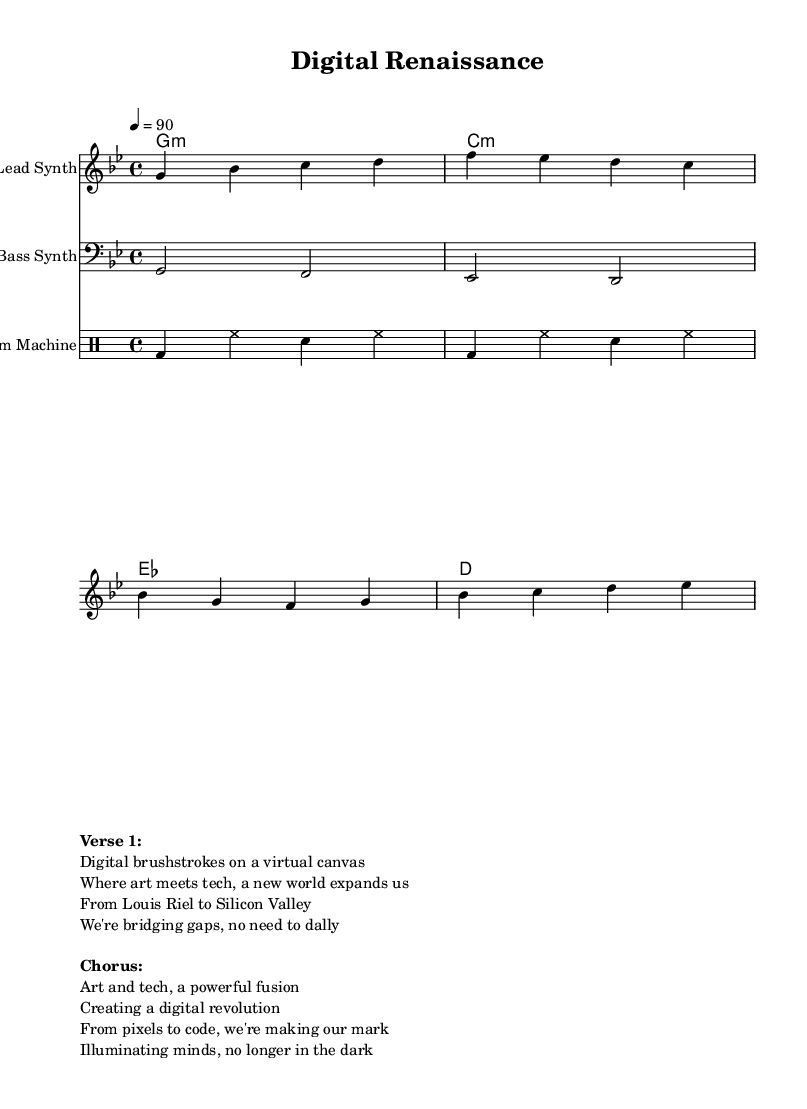What is the key signature of this music? The key signature is G minor, which has two flats: B flat and E flat. We identify the key signature from the beginning of the staff, which indicates the tonal center of the piece.
Answer: G minor What is the time signature of this music? The time signature is four-four, which means there are four beats in each measure and the quarter note gets one beat. This can be found at the beginning of the score, where the time signature is notated.
Answer: Four-four What is the tempo of the piece? The tempo marking indicates a speed of ninety beats per minute. This is noted at the start of the score, providing guidance on how quickly to perform the piece.
Answer: Ninety How many measures are in the lead synth part? The lead synth part contains four measures, as seen by counting the bar lines separating the different sections of music notation.
Answer: Four measures What is the instrument used for the bass part? The bass synth is specified as the instrument used for the bass part. This can be determined by the staff label provided at the beginning of the bass section.
Answer: Bass synth What is the primary theme of the verse? The primary theme of the verse revolves around the intersection of art and technology, as highlighted in the lyrics. Reasoning through the lyrics, we see references to digital canvases and bridging gaps between different worlds.
Answer: Intersection of art and technology How does the chorus emphasize the song's message? The chorus emphasizes the power of the fusion between art and tech, reflecting the overall theme of the song. Analyzing the lyrics, we see particularly strong phrases regarding creating a revolution and illuminating minds, which resonate with the concept of innovation.
Answer: Power of fusion 